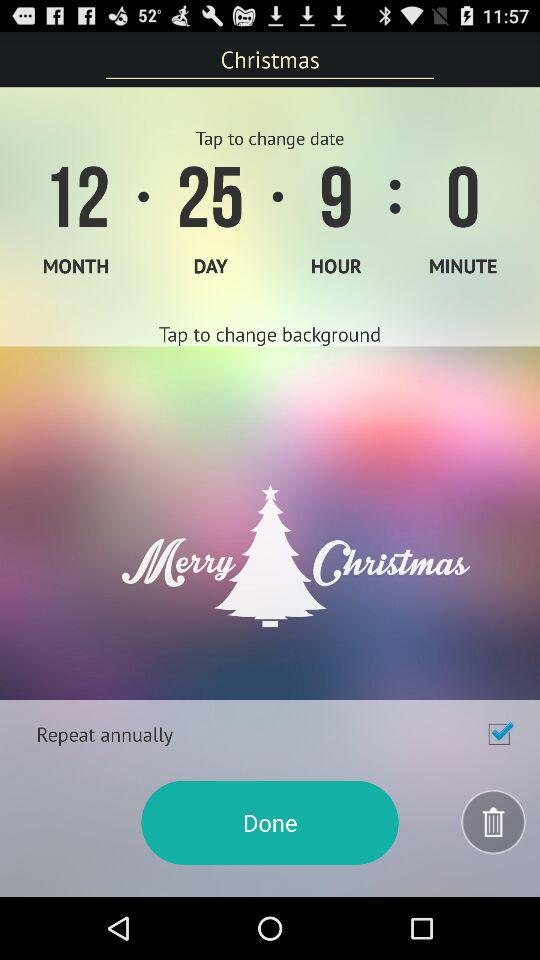Which option has been checked? The checked option is "Repeat annually". 